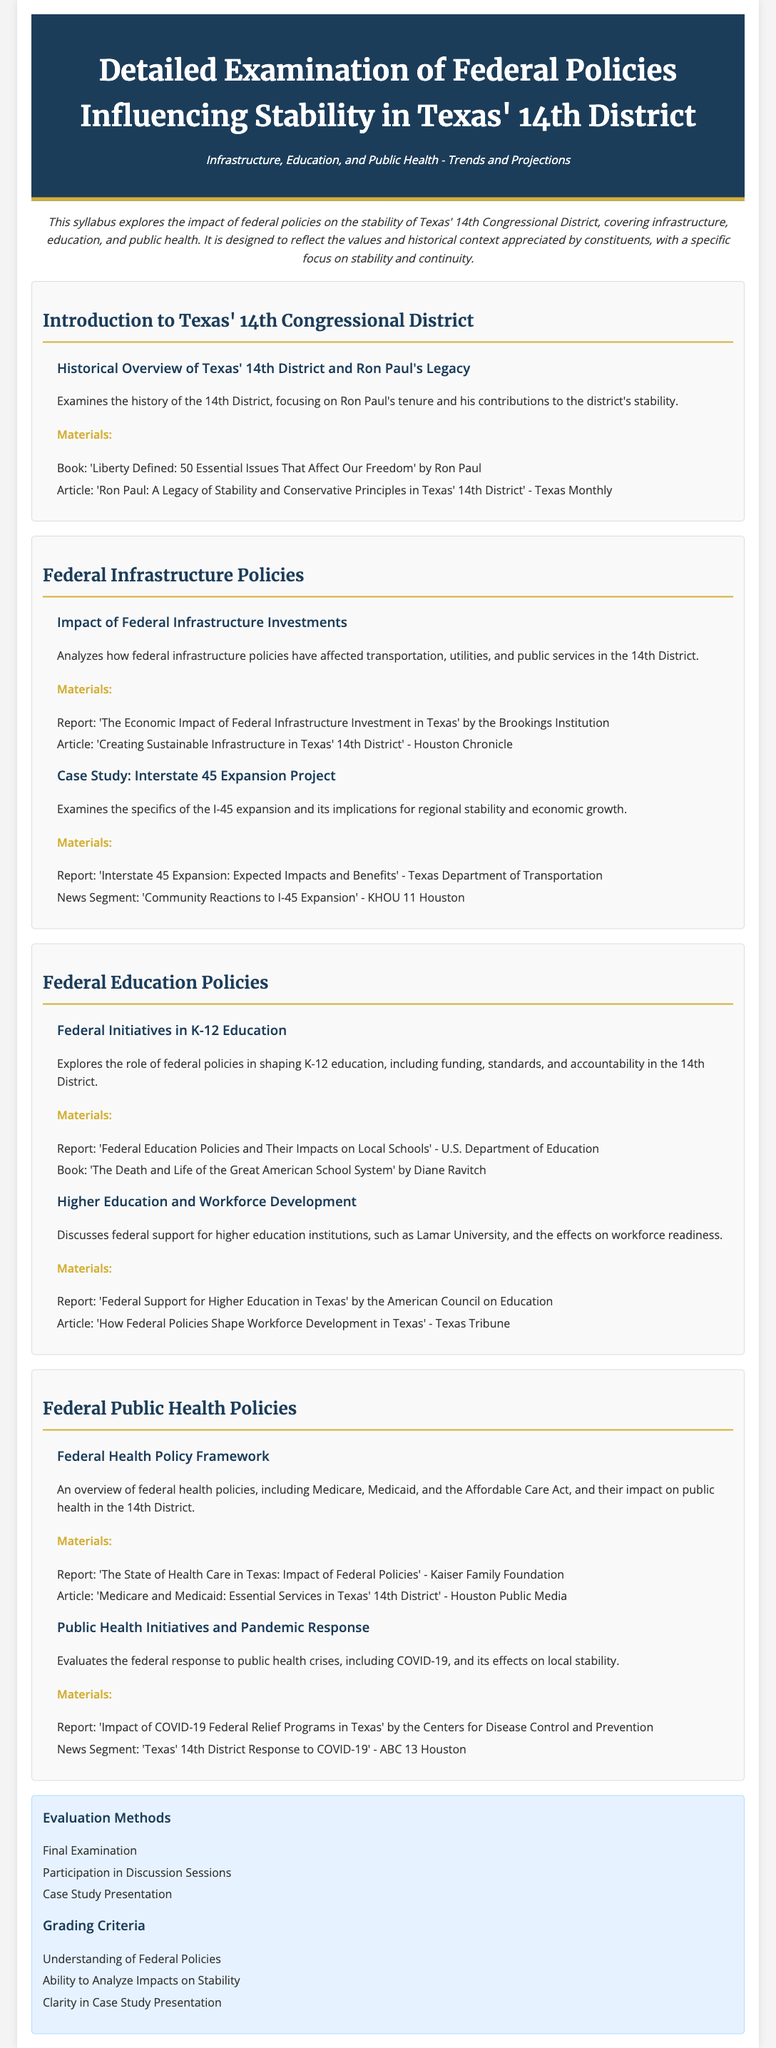What is the title of the syllabus? The title is clearly stated at the top of the document, focusing on federal policies in Texas' 14th District.
Answer: Detailed Examination of Federal Policies Influencing Stability in Texas' 14th District Who is a notable figure associated with Texas' 14th District? The syllabus references Ron Paul, highlighting his legacy and contributions.
Answer: Ron Paul What type of policies does the syllabus cover? The syllabus mentions three main areas affected by federal policies, as stated in the introduction.
Answer: Infrastructure, Education, and Public Health What is one federal report mentioned regarding infrastructure? The syllabus lists several materials, including reports on infrastructure investments in the district.
Answer: The Economic Impact of Federal Infrastructure Investment in Texas How many modules are there in the syllabus? The document outlines the structure, revealing the total number of modules present.
Answer: Four What is one of the evaluation methods? The evaluation section lists various methods for assessing understanding, providing a specific example.
Answer: Final Examination Which article discusses Ron Paul's legacy? The syllabus provides specific articles related to the historical overview of the 14th District.
Answer: Ron Paul: A Legacy of Stability and Conservative Principles in Texas' 14th District What is a focus of the public health module? The public health module describes overarching themes and initiatives tied to federal health policies.
Answer: Federal Health Policy Framework Which educational institution is mentioned in the context of higher education support? The syllabus refers to a specific university when discussing the role of federal policies on education.
Answer: Lamar University 